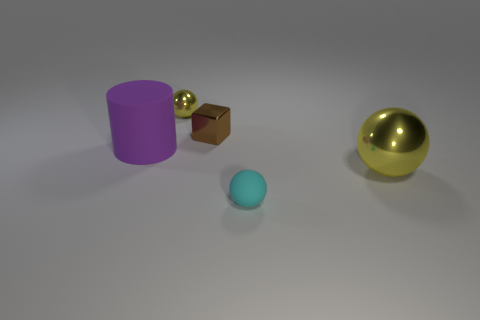There is a sphere behind the large metallic sphere; is it the same color as the metal thing that is on the right side of the brown object?
Make the answer very short. Yes. Is there another sphere of the same color as the large metal ball?
Your response must be concise. Yes. There is a big object that is the same color as the small metal ball; what is its material?
Provide a short and direct response. Metal. Is there a purple object of the same shape as the brown thing?
Offer a very short reply. No. Are there fewer gray shiny spheres than small metallic blocks?
Provide a short and direct response. Yes. Do the yellow metal sphere right of the tiny yellow sphere and the yellow metal ball that is behind the big purple matte cylinder have the same size?
Provide a short and direct response. No. How many objects are small spheres or large spheres?
Offer a very short reply. 3. What size is the yellow ball that is behind the big yellow sphere?
Your answer should be very brief. Small. What number of small cyan matte objects are on the right side of the ball that is behind the yellow metal thing that is right of the cyan sphere?
Give a very brief answer. 1. Is the tiny matte object the same color as the tiny block?
Offer a terse response. No. 